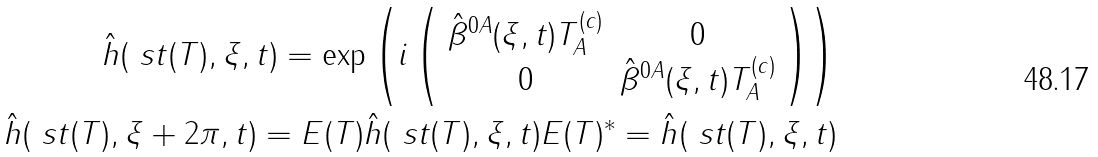Convert formula to latex. <formula><loc_0><loc_0><loc_500><loc_500>\hat { h } ( \ s t ( T ) , \xi , t ) = \exp \left ( i \left ( \begin{array} { c c } \hat { \beta } ^ { 0 A } ( \xi , t ) T _ { A } ^ { ( c ) } & 0 \\ 0 & \hat { \beta } ^ { 0 A } ( \xi , t ) T _ { A } ^ { ( c ) } \end{array} \right ) \right ) \\ \hat { h } ( \ s t ( T ) , \xi + 2 \pi , t ) = E ( T ) \hat { h } ( \ s t ( T ) , \xi , t ) E ( T ) ^ { * } = \hat { h } ( \ s t ( T ) , \xi , t )</formula> 